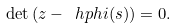Convert formula to latex. <formula><loc_0><loc_0><loc_500><loc_500>\det \left ( z - \ h p h i ( s ) \right ) = 0 .</formula> 